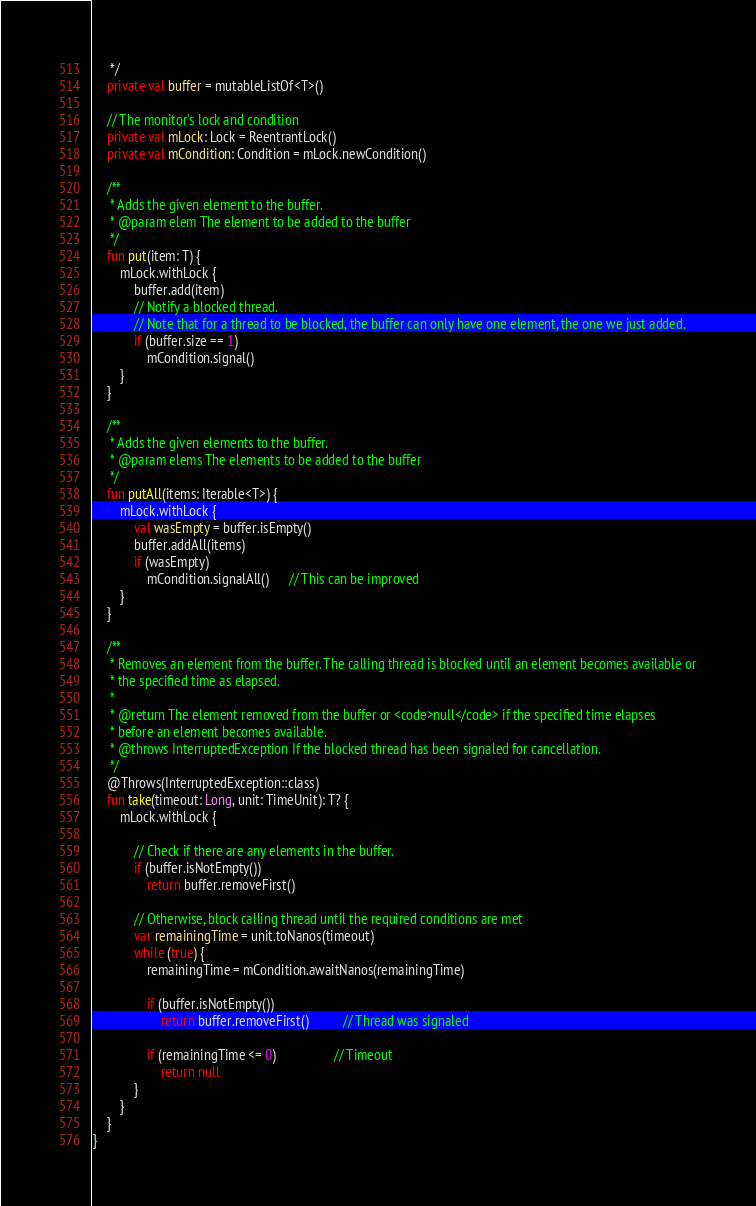Convert code to text. <code><loc_0><loc_0><loc_500><loc_500><_Kotlin_>     */
    private val buffer = mutableListOf<T>()

    // The monitor's lock and condition
    private val mLock: Lock = ReentrantLock()
    private val mCondition: Condition = mLock.newCondition()

    /**
     * Adds the given element to the buffer.
     * @param elem The element to be added to the buffer
     */
    fun put(item: T) {
        mLock.withLock {
            buffer.add(item)
            // Notify a blocked thread.
            // Note that for a thread to be blocked, the buffer can only have one element, the one we just added.
            if (buffer.size == 1)
                mCondition.signal()
        }
    }

    /**
     * Adds the given elements to the buffer.
     * @param elems The elements to be added to the buffer
     */
    fun putAll(items: Iterable<T>) {
        mLock.withLock {
            val wasEmpty = buffer.isEmpty()
            buffer.addAll(items)
            if (wasEmpty)
                mCondition.signalAll()      // This can be improved
        }
    }

    /**
     * Removes an element from the buffer. The calling thread is blocked until an element becomes available or
     * the specified time as elapsed.
     *
     * @return The element removed from the buffer or <code>null</code> if the specified time elapses
     * before an element becomes available.
     * @throws InterruptedException If the blocked thread has been signaled for cancellation.
     */
    @Throws(InterruptedException::class)
    fun take(timeout: Long, unit: TimeUnit): T? {
        mLock.withLock {

            // Check if there are any elements in the buffer.
            if (buffer.isNotEmpty())
                return buffer.removeFirst()

            // Otherwise, block calling thread until the required conditions are met
            var remainingTime = unit.toNanos(timeout)
            while (true) {
                remainingTime = mCondition.awaitNanos(remainingTime)

                if (buffer.isNotEmpty())
                    return buffer.removeFirst()          // Thread was signaled

                if (remainingTime <= 0)                 // Timeout
                    return null
            }
        }
    }
}</code> 